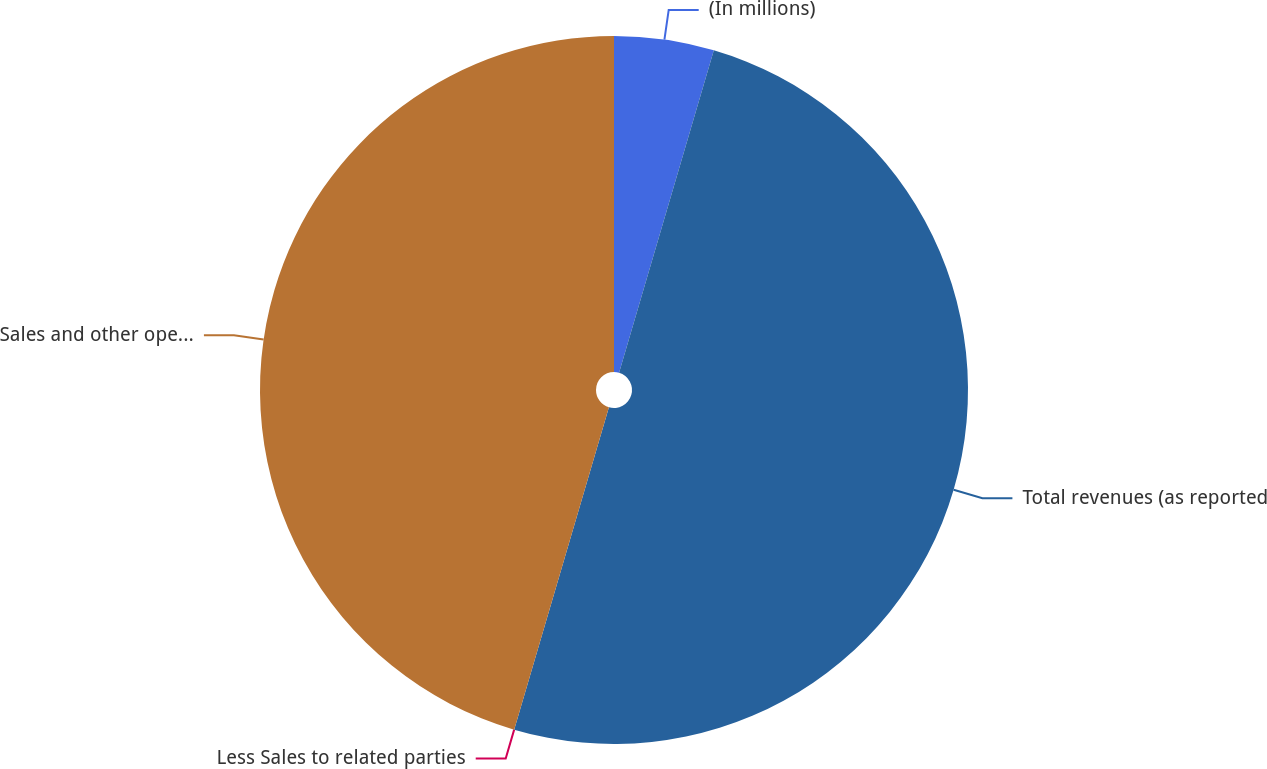<chart> <loc_0><loc_0><loc_500><loc_500><pie_chart><fcel>(In millions)<fcel>Total revenues (as reported<fcel>Less Sales to related parties<fcel>Sales and other operating<nl><fcel>4.55%<fcel>50.0%<fcel>0.0%<fcel>45.45%<nl></chart> 